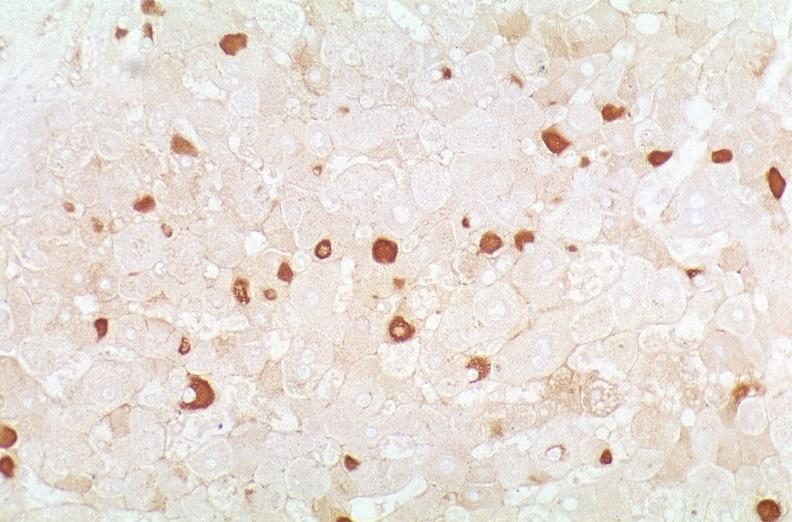s liver present?
Answer the question using a single word or phrase. Yes 